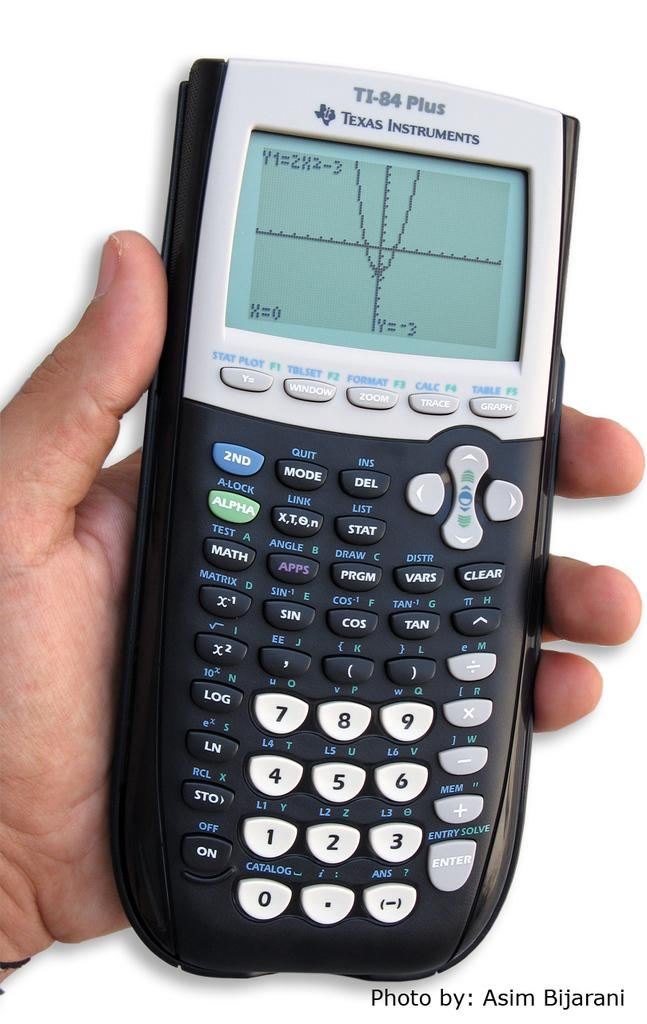<image>
Write a terse but informative summary of the picture. the word plus is on the front of a calculator 